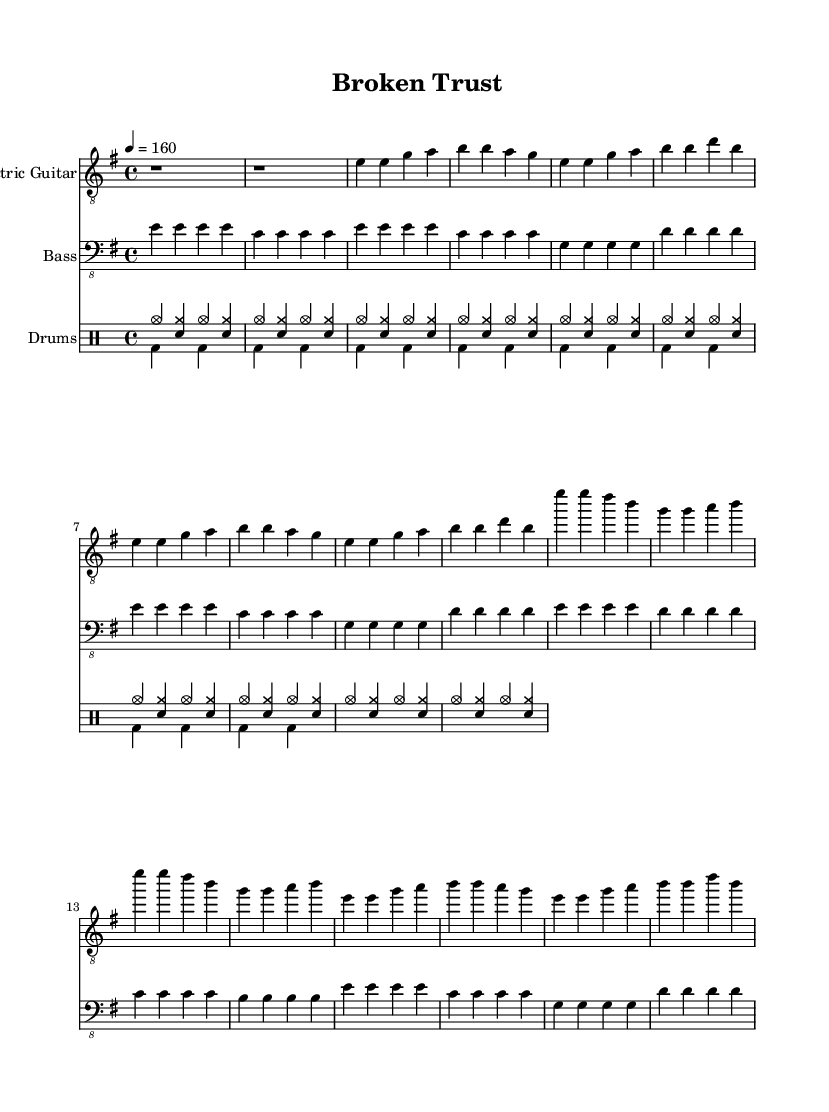What is the key signature of this music? The key signature indicated at the beginning shows one sharp, which corresponds to E minor.
Answer: E minor What is the time signature used in this piece? The time signature is located at the beginning of the score, which is written as a fraction and indicates four beats per measure. This is represented as 4/4.
Answer: 4/4 What is the tempo marking for this piece? The tempo marking is shown at the beginning of the score, indicating a speed of quarter note equals 160 beats per minute.
Answer: 160 How many measures are in Verse 1? Counting the segments between the bar lines, Verse 1 contains eight measures in total.
Answer: Eight What instruments are indicated in the score? The score includes three staves for different instruments: Electric Guitar, Bass, and Drums, confirming that these are the instruments involved in this piece.
Answer: Electric Guitar, Bass, Drums What does the chorus section consist of in terms of measures? The chorus appears to have eight measures that are notably repeated from Verse 1, showing a structure that emphasizes the main theme of the song.
Answer: Eight How is the intensity expressed musically in this piece? The intensity is conveyed through the use of a high tempo, aggressive rhythms in the drum parts, and power chords on the electric guitar, which all contribute to an overall sense of urgency and frustration aligned with the theme.
Answer: Aggressive rhythms, high tempo 